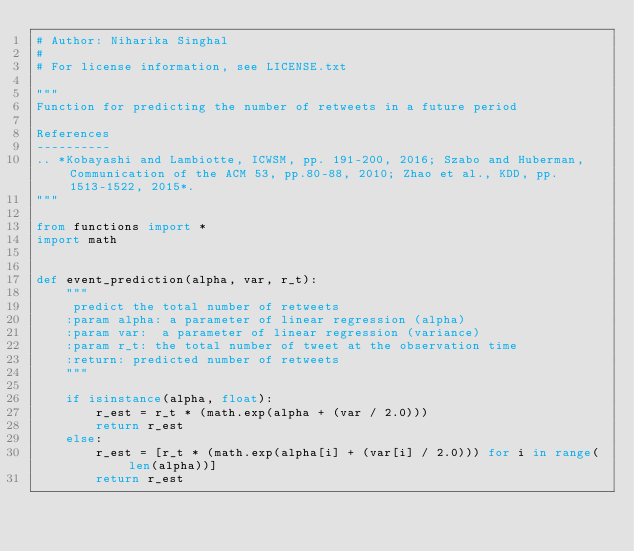<code> <loc_0><loc_0><loc_500><loc_500><_Python_># Author: Niharika Singhal
#
# For license information, see LICENSE.txt

"""
Function for predicting the number of retweets in a future period

References
----------
.. *Kobayashi and Lambiotte, ICWSM, pp. 191-200, 2016; Szabo and Huberman, Communication of the ACM 53, pp.80-88, 2010; Zhao et al., KDD, pp. 1513-1522, 2015*.
"""

from functions import *
import math


def event_prediction(alpha, var, r_t):
    """
     predict the total number of retweets
    :param alpha: a parameter of linear regression (alpha)
    :param var:  a parameter of linear regression (variance)
    :param r_t: the total number of tweet at the observation time
    :return: predicted number of retweets
    """

    if isinstance(alpha, float):
        r_est = r_t * (math.exp(alpha + (var / 2.0)))
        return r_est
    else:
        r_est = [r_t * (math.exp(alpha[i] + (var[i] / 2.0))) for i in range(len(alpha))]
        return r_est
</code> 